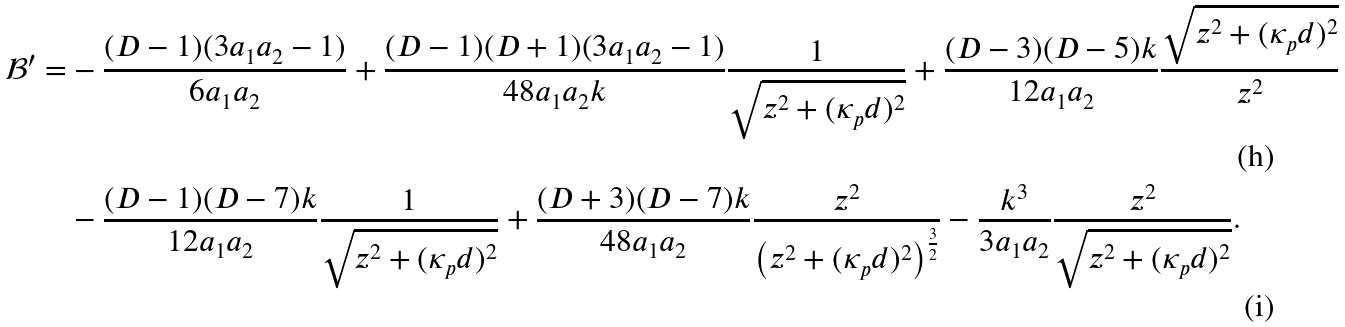Convert formula to latex. <formula><loc_0><loc_0><loc_500><loc_500>\mathcal { B } ^ { \prime } = & - \frac { ( D - 1 ) ( 3 a _ { 1 } a _ { 2 } - 1 ) } { 6 a _ { 1 } a _ { 2 } } + \frac { ( D - 1 ) ( D + 1 ) ( 3 a _ { 1 } a _ { 2 } - 1 ) } { 4 8 a _ { 1 } a _ { 2 } k } \frac { 1 } { \sqrt { z ^ { 2 } + ( \kappa _ { p } d ) ^ { 2 } } } + \frac { ( D - 3 ) ( D - 5 ) k } { 1 2 a _ { 1 } a _ { 2 } } \frac { \sqrt { z ^ { 2 } + ( \kappa _ { p } d ) ^ { 2 } } } { z ^ { 2 } } \\ & - \frac { ( D - 1 ) ( D - 7 ) k } { 1 2 a _ { 1 } a _ { 2 } } \frac { 1 } { \sqrt { z ^ { 2 } + ( \kappa _ { p } d ) ^ { 2 } } } + \frac { ( D + 3 ) ( D - 7 ) k } { 4 8 a _ { 1 } a _ { 2 } } \frac { z ^ { 2 } } { \left ( z ^ { 2 } + ( \kappa _ { p } d ) ^ { 2 } \right ) ^ { \frac { 3 } { 2 } } } - \frac { k ^ { 3 } } { 3 a _ { 1 } a _ { 2 } } \frac { z ^ { 2 } } { \sqrt { z ^ { 2 } + ( \kappa _ { p } d ) ^ { 2 } } } .</formula> 